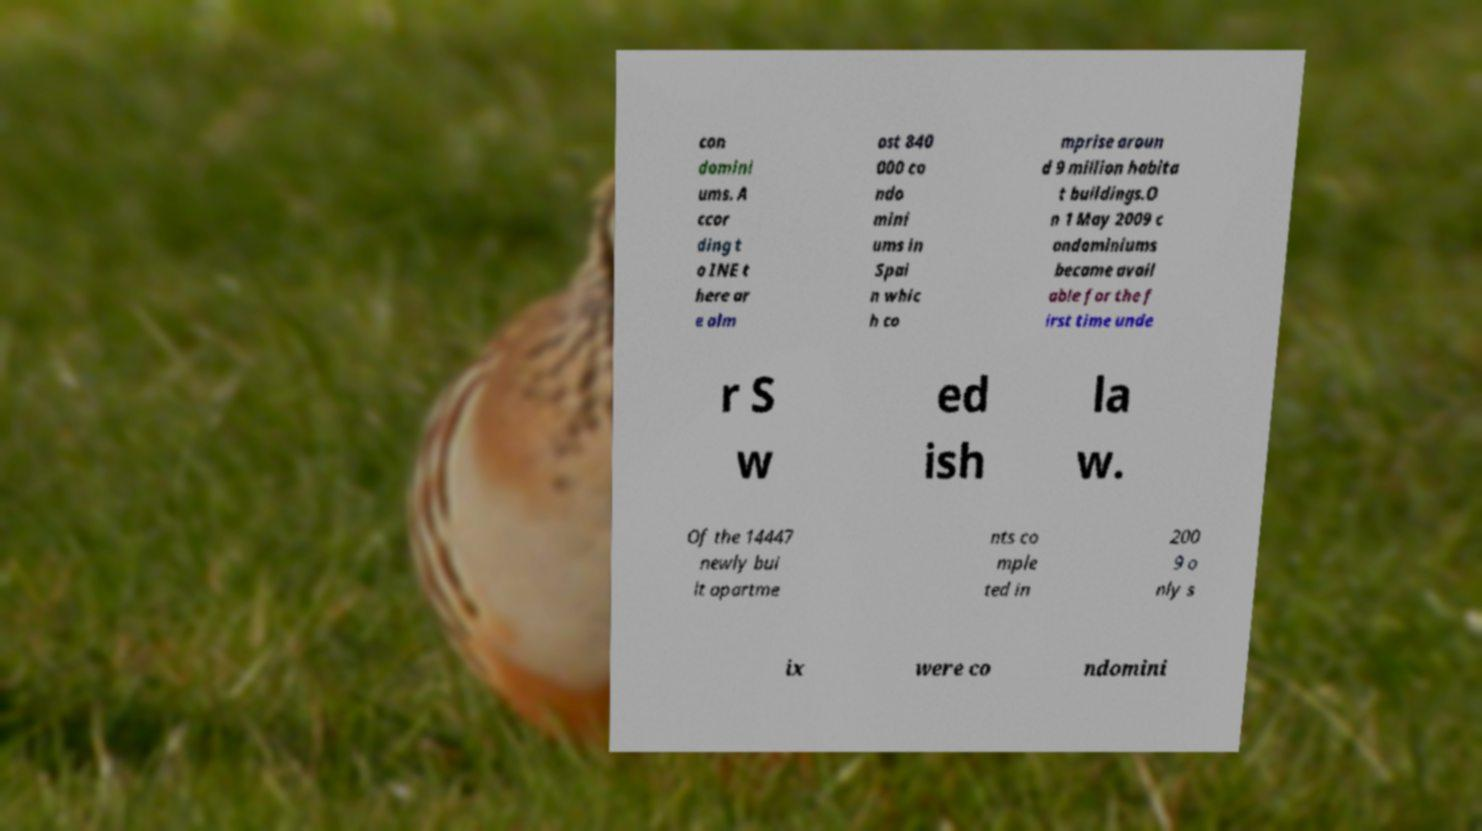Can you read and provide the text displayed in the image?This photo seems to have some interesting text. Can you extract and type it out for me? con domini ums. A ccor ding t o INE t here ar e alm ost 840 000 co ndo mini ums in Spai n whic h co mprise aroun d 9 million habita t buildings.O n 1 May 2009 c ondominiums became avail able for the f irst time unde r S w ed ish la w. Of the 14447 newly bui lt apartme nts co mple ted in 200 9 o nly s ix were co ndomini 